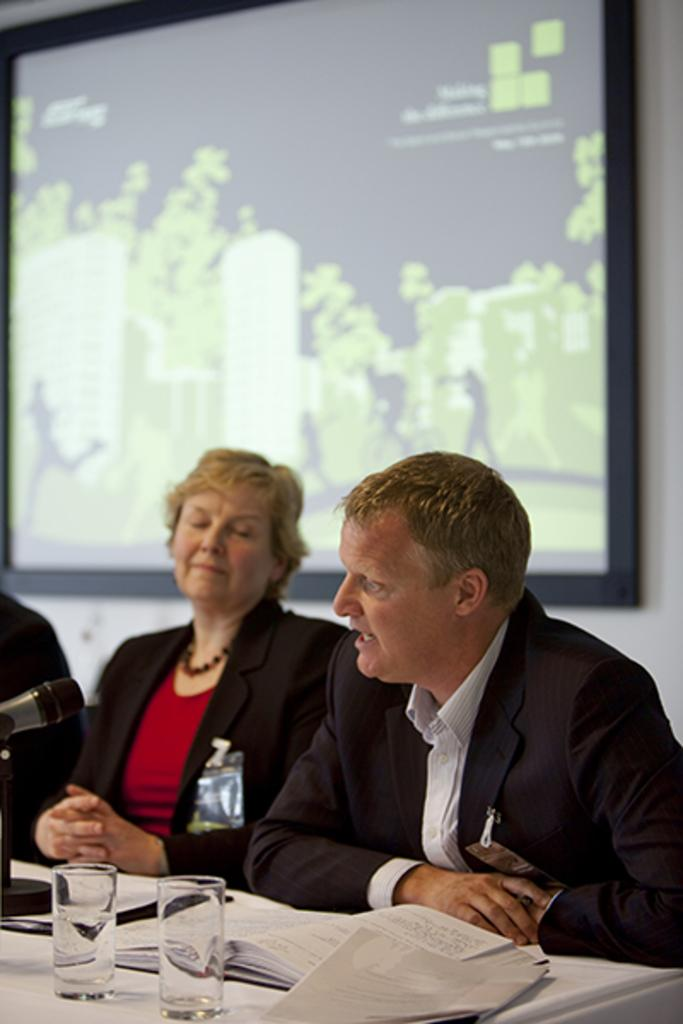What is on the wall in the background of the image? There is a screen on the wall in the background. How many people are in the image? There is a woman and a man in the image. What is on the table in the image? There is a book, water glasses, a microphone, and an unspecified object on the table. What type of arm is visible on the sidewalk in the image? There is no arm or sidewalk present in the image. What kind of truck is parked near the table in the image? There is no truck present in the image; it only features a screen, a table, and the people. 